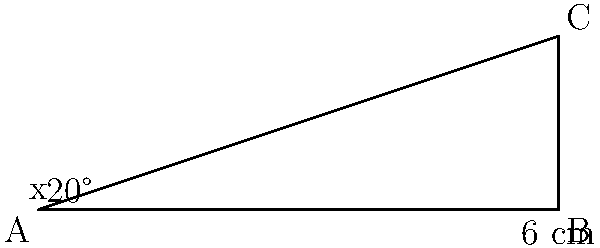You're tuning your bouzouki, a traditional Greek instrument similar to a guitar. The string forms a right triangle with the fretboard. If the fretboard is 6 cm long and the string makes a 20° angle with it, what is the length of the string to the nearest millimeter? Let's approach this step-by-step:

1) We have a right triangle where:
   - The base (fretboard length) is 6 cm
   - The angle between the string and the fretboard is 20°
   - We need to find the length of the string (the hypotenuse)

2) In a right triangle, we can use the cosine function to find the hypotenuse:

   $\cos(\theta) = \frac{\text{adjacent}}{\text{hypotenuse}}$

3) Rearranging this formula:

   $\text{hypotenuse} = \frac{\text{adjacent}}{\cos(\theta)}$

4) We know:
   - adjacent = 6 cm
   - $\theta = 20°$

5) Plugging these values into our formula:

   $\text{string length} = \frac{6}{\cos(20°)}$

6) Using a calculator:

   $\text{string length} = \frac{6}{0.9397} \approx 6.3849$ cm

7) Rounding to the nearest millimeter:

   $\text{string length} \approx 6.4$ cm
Answer: 6.4 cm 